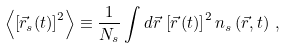<formula> <loc_0><loc_0><loc_500><loc_500>\left < \left [ \vec { r } _ { s } ( t ) \right ] ^ { 2 } \right > \equiv \frac { 1 } { N _ { s } } \int d \vec { r } \, \left [ \vec { r } \, ( t ) \right ] ^ { 2 } n _ { s } \left ( \vec { r } , t \right ) \, ,</formula> 